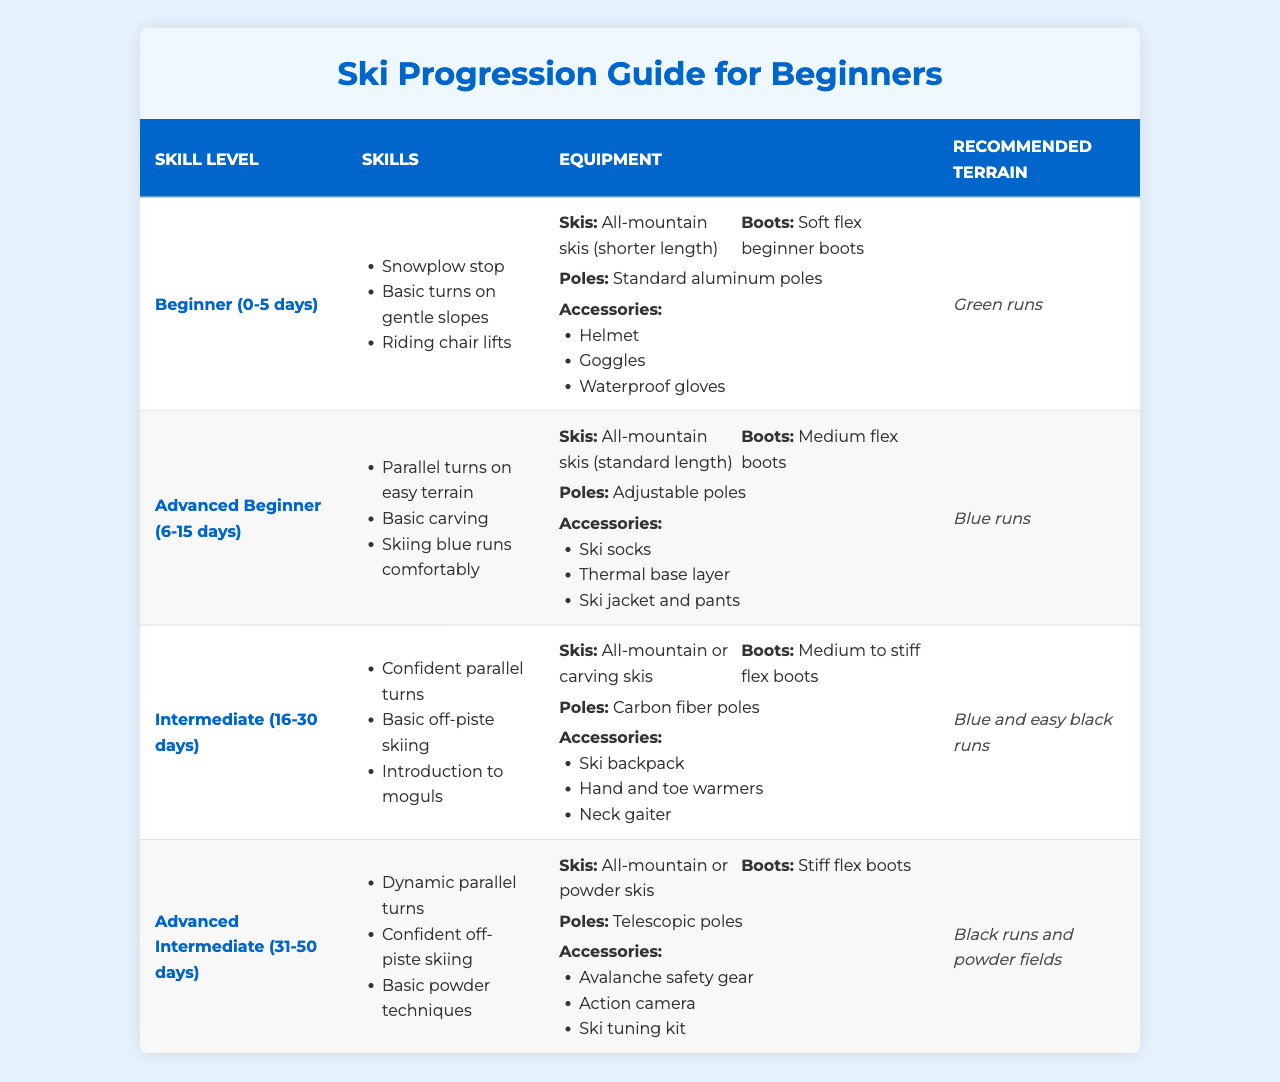What skills are needed for a novice skier? According to the table, a novice skier (Beginner level) needs to learn the snowplow stop, basic turns on gentle slopes, and how to ride chair lifts.
Answer: Snowplow stop, basic turns on gentle slopes, riding chair lifts What equipment is recommended for the Advanced Beginner level? The table lists the recommended equipment for the Advanced Beginner level as all-mountain skis (standard length), medium flex boots, adjustable poles, ski socks, a thermal base layer, and ski jacket and pants.
Answer: All-mountain skis, medium flex boots, adjustable poles, ski socks, thermal base layer, ski jacket and pants Is it true that all-mountain skis are recommended for the Intermediate level? Yes, the table indicates that both all-mountain and carving skis are suitable for the Intermediate level.
Answer: Yes What is the recommended terrain for a Beginner skier? The Beginner level in the table specifies that the recommended terrain is green runs.
Answer: Green runs How do the recommended accessories differ from Beginner to Advanced Intermediate levels? Beginners need a helmet, goggles, and waterproof gloves, while Advanced Intermediate skiers require avalanche safety gear, an action camera, and a ski tuning kit. There's a noticeable shift from basic safety gear to gear focused on advanced techniques and safety measures.
Answer: Different accessories for each level What types of skis are suggested for skiers at the Advanced Intermediate level? The table suggests all-mountain or powder skis for Advanced Intermediate skiers.
Answer: All-mountain or powder skis Are the recommended boots for the Intermediate level softer than those for the Advanced Intermediate level? The Intermediate level recommends medium to stiff flex boots, while the Advanced Intermediate level suggests stiff flex boots. Therefore, the Intermediate level boots are not softer.
Answer: No What skills must a skier master before they can ski comfortably on blue runs? The table shows that to ski comfortably on blue runs, a skier must master parallel turns on easy terrain and basic carving as per the Advanced Beginner level.
Answer: Parallel turns on easy terrain, basic carving If a skier has completed 20 days of skiing, what skill level are they likely at? Based on the table, after 20 days, a skier is likely at the Intermediate level (16-30 days) and should demonstrate confident parallel turns and basic off-piste skiing.
Answer: Intermediate What is the difference in recommended terrain between the Beginner and Advanced Intermediate levels? For the Beginner level, the recommended terrain is green runs, while for the Advanced Intermediate level, it shifts to black runs and powder fields. The range of difficulty increases as skiers progress.
Answer: Green runs vs. black runs and powder fields 